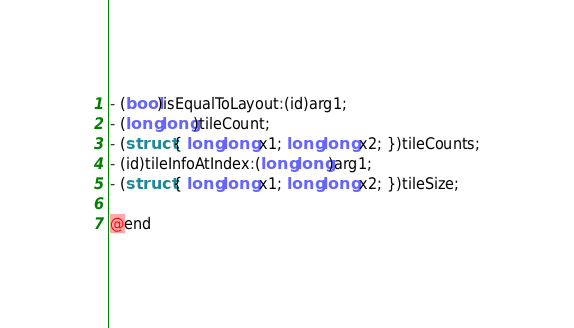<code> <loc_0><loc_0><loc_500><loc_500><_C_>- (bool)isEqualToLayout:(id)arg1;
- (long long)tileCount;
- (struct { long long x1; long long x2; })tileCounts;
- (id)tileInfoAtIndex:(long long)arg1;
- (struct { long long x1; long long x2; })tileSize;

@end
</code> 